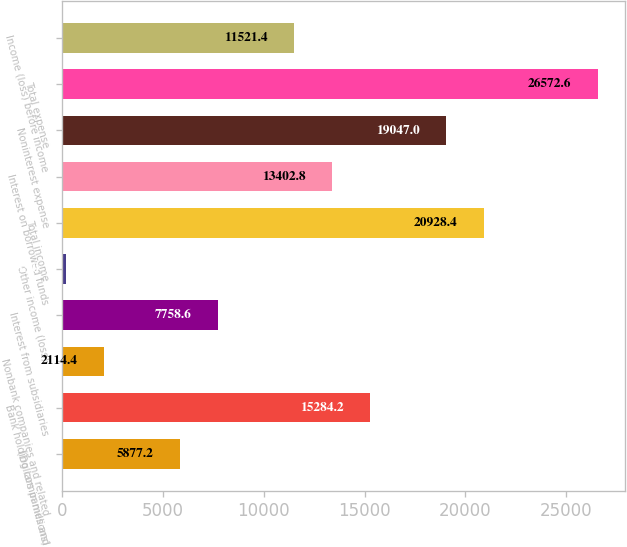Convert chart to OTSL. <chart><loc_0><loc_0><loc_500><loc_500><bar_chart><fcel>(Dollars in millions)<fcel>Bank holding companies and<fcel>Nonbank companies and related<fcel>Interest from subsidiaries<fcel>Other income (loss)<fcel>Total income<fcel>Interest on borrowed funds<fcel>Noninterest expense<fcel>Total expense<fcel>Income (loss) before income<nl><fcel>5877.2<fcel>15284.2<fcel>2114.4<fcel>7758.6<fcel>233<fcel>20928.4<fcel>13402.8<fcel>19047<fcel>26572.6<fcel>11521.4<nl></chart> 